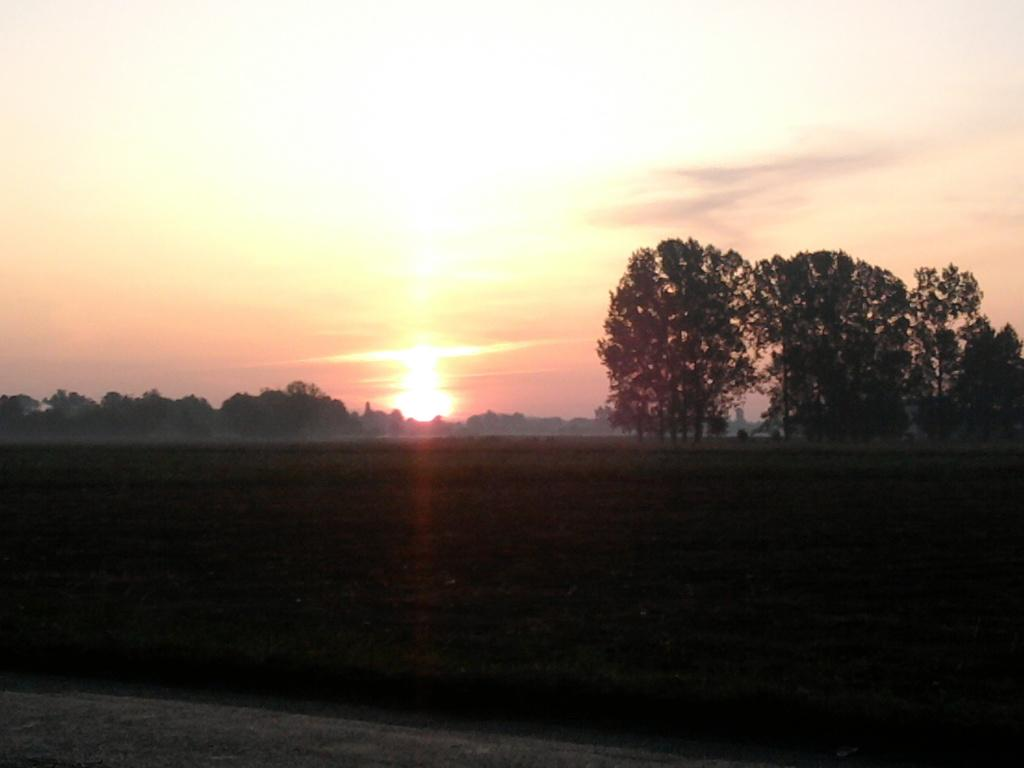What type of vegetation can be seen in the image? There are trees in the image. What is the color of the trees in the image? The trees are green in color. What can be seen in the background of the image? The sky is visible in the background of the image. What colors are present in the sky in the image? The sky has a white and light red color. Where is the market located in the image? There is no market present in the image; it only features trees and a sky background. 